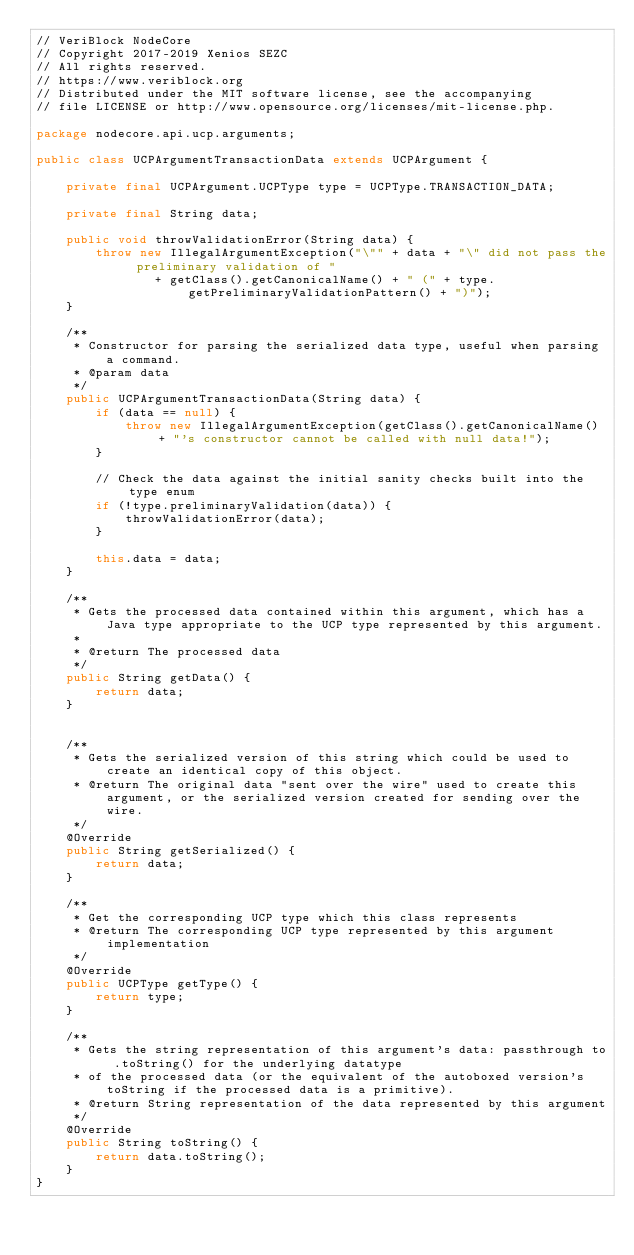Convert code to text. <code><loc_0><loc_0><loc_500><loc_500><_Java_>// VeriBlock NodeCore
// Copyright 2017-2019 Xenios SEZC
// All rights reserved.
// https://www.veriblock.org
// Distributed under the MIT software license, see the accompanying
// file LICENSE or http://www.opensource.org/licenses/mit-license.php.

package nodecore.api.ucp.arguments;

public class UCPArgumentTransactionData extends UCPArgument {

    private final UCPArgument.UCPType type = UCPType.TRANSACTION_DATA;

    private final String data;

    public void throwValidationError(String data) {
        throw new IllegalArgumentException("\"" + data + "\" did not pass the preliminary validation of "
                + getClass().getCanonicalName() + " (" + type.getPreliminaryValidationPattern() + ")");
    }

    /**
     * Constructor for parsing the serialized data type, useful when parsing a command.
     * @param data
     */
    public UCPArgumentTransactionData(String data) {
        if (data == null) {
            throw new IllegalArgumentException(getClass().getCanonicalName() + "'s constructor cannot be called with null data!");
        }

        // Check the data against the initial sanity checks built into the type enum
        if (!type.preliminaryValidation(data)) {
            throwValidationError(data);
        }

        this.data = data;
    }

    /**
     * Gets the processed data contained within this argument, which has a Java type appropriate to the UCP type represented by this argument.
     *
     * @return The processed data
     */
    public String getData() {
        return data;
    }


    /**
     * Gets the serialized version of this string which could be used to create an identical copy of this object.
     * @return The original data "sent over the wire" used to create this argument, or the serialized version created for sending over the wire.
     */
    @Override
    public String getSerialized() {
        return data;
    }

    /**
     * Get the corresponding UCP type which this class represents
     * @return The corresponding UCP type represented by this argument implementation
     */
    @Override
    public UCPType getType() {
        return type;
    }

    /**
     * Gets the string representation of this argument's data: passthrough to .toString() for the underlying datatype
     * of the processed data (or the equivalent of the autoboxed version's toString if the processed data is a primitive).
     * @return String representation of the data represented by this argument
     */
    @Override
    public String toString() {
        return data.toString();
    }
}
</code> 